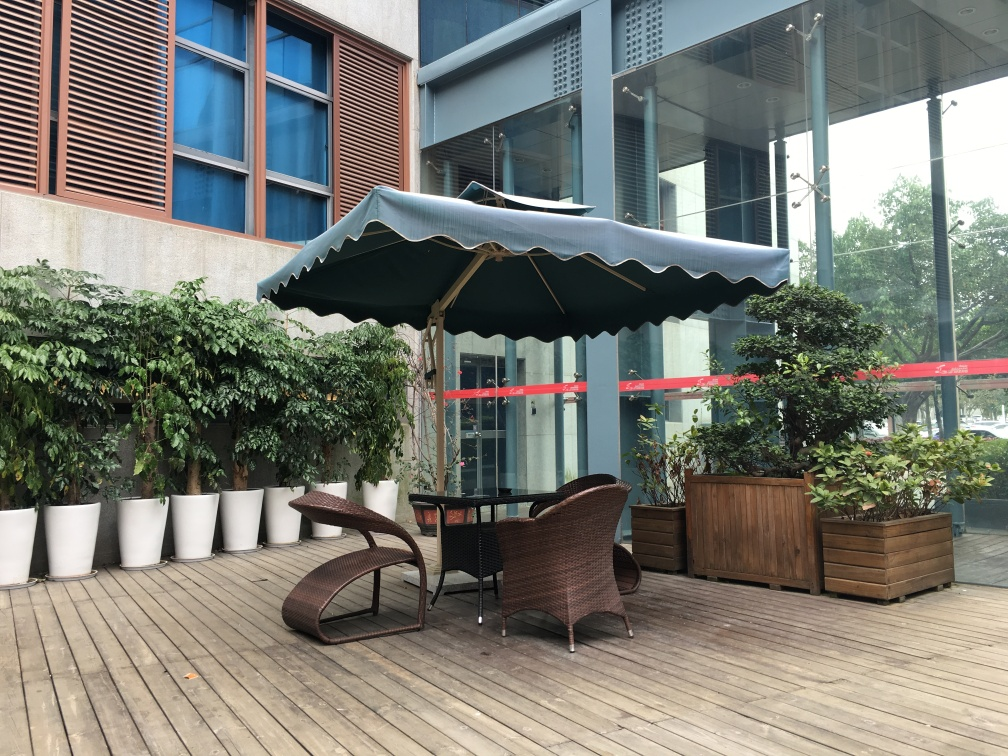How is the seating area arranged here? The seating area features a tasteful arrangement consisting of a curved, wicker lounge chair and a round, glass-top table, all sheltered beneath a large, scalloped-edged umbrella, providing a comfortable and shaded spot for relaxation or casual meetings. What can you tell me about the plants in this space? The area is adorned with an array of lush greenery, including potted plants arranged in a row against the wall, and larger shrubs contained in wooden planters. These plants add a natural and refreshing touch to the space, potentially improving air quality and contributing to a serene ambiance. 